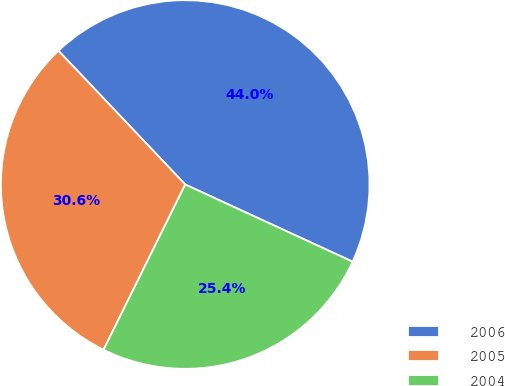Convert chart to OTSL. <chart><loc_0><loc_0><loc_500><loc_500><pie_chart><fcel>2006<fcel>2005<fcel>2004<nl><fcel>43.95%<fcel>30.62%<fcel>25.43%<nl></chart> 